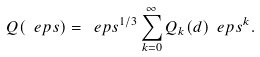<formula> <loc_0><loc_0><loc_500><loc_500>Q ( \ e p s ) = \ e p s ^ { 1 / 3 } \sum _ { k = 0 } ^ { \infty } Q _ { k } ( d ) \ e p s ^ { k } .</formula> 